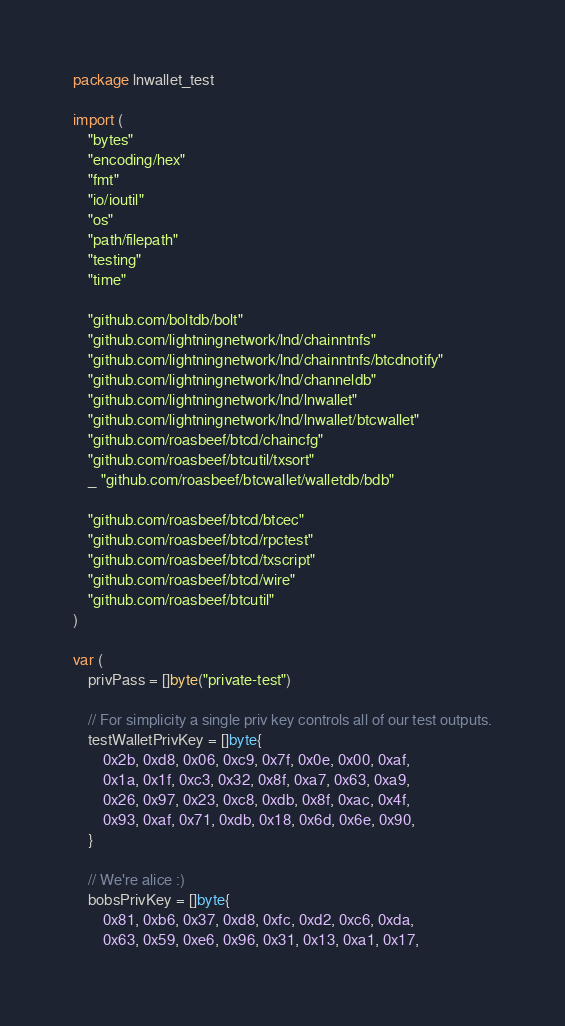Convert code to text. <code><loc_0><loc_0><loc_500><loc_500><_Go_>package lnwallet_test

import (
	"bytes"
	"encoding/hex"
	"fmt"
	"io/ioutil"
	"os"
	"path/filepath"
	"testing"
	"time"

	"github.com/boltdb/bolt"
	"github.com/lightningnetwork/lnd/chainntnfs"
	"github.com/lightningnetwork/lnd/chainntnfs/btcdnotify"
	"github.com/lightningnetwork/lnd/channeldb"
	"github.com/lightningnetwork/lnd/lnwallet"
	"github.com/lightningnetwork/lnd/lnwallet/btcwallet"
	"github.com/roasbeef/btcd/chaincfg"
	"github.com/roasbeef/btcutil/txsort"
	_ "github.com/roasbeef/btcwallet/walletdb/bdb"

	"github.com/roasbeef/btcd/btcec"
	"github.com/roasbeef/btcd/rpctest"
	"github.com/roasbeef/btcd/txscript"
	"github.com/roasbeef/btcd/wire"
	"github.com/roasbeef/btcutil"
)

var (
	privPass = []byte("private-test")

	// For simplicity a single priv key controls all of our test outputs.
	testWalletPrivKey = []byte{
		0x2b, 0xd8, 0x06, 0xc9, 0x7f, 0x0e, 0x00, 0xaf,
		0x1a, 0x1f, 0xc3, 0x32, 0x8f, 0xa7, 0x63, 0xa9,
		0x26, 0x97, 0x23, 0xc8, 0xdb, 0x8f, 0xac, 0x4f,
		0x93, 0xaf, 0x71, 0xdb, 0x18, 0x6d, 0x6e, 0x90,
	}

	// We're alice :)
	bobsPrivKey = []byte{
		0x81, 0xb6, 0x37, 0xd8, 0xfc, 0xd2, 0xc6, 0xda,
		0x63, 0x59, 0xe6, 0x96, 0x31, 0x13, 0xa1, 0x17,</code> 